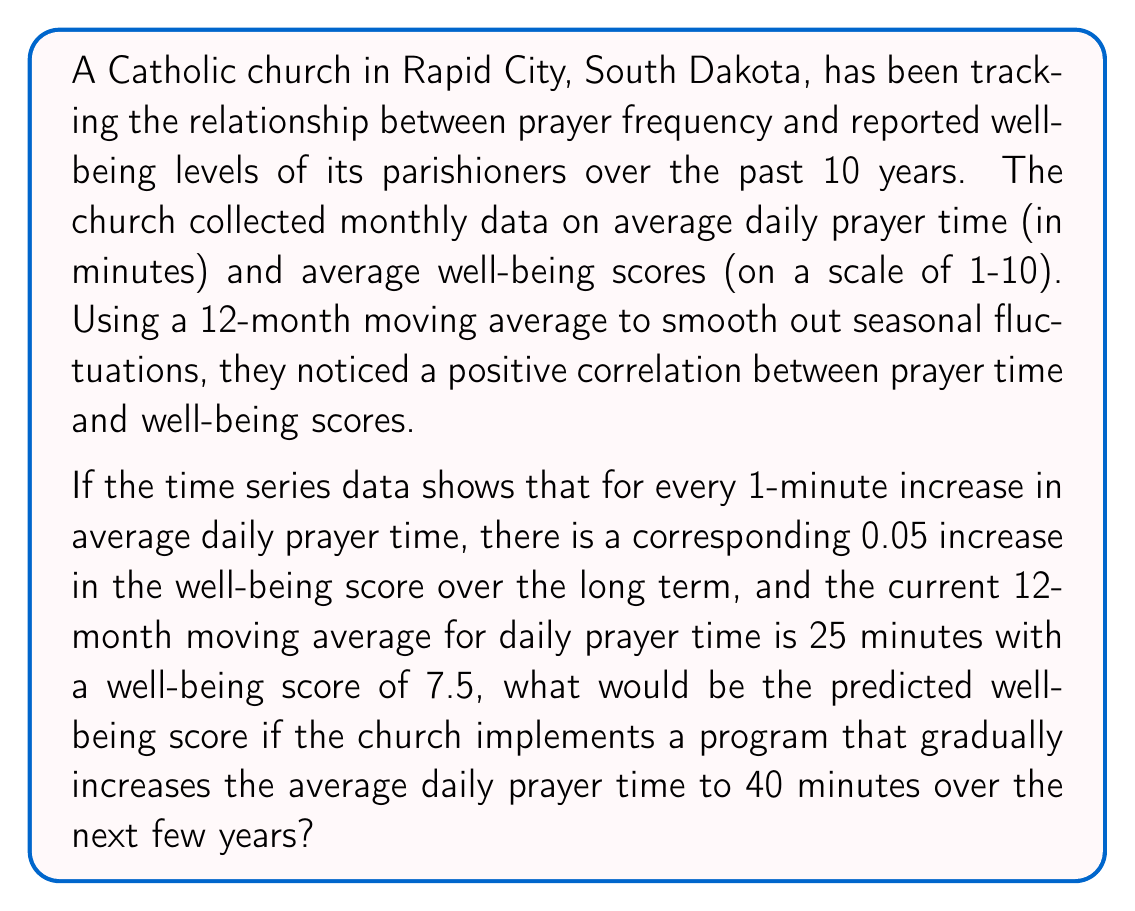Could you help me with this problem? To solve this problem, we need to follow these steps:

1. Understand the given information:
   - There is a positive correlation between prayer time and well-being scores.
   - For every 1-minute increase in average daily prayer time, there is a 0.05 increase in the well-being score.
   - Current 12-month moving average for daily prayer time is 25 minutes.
   - Current well-being score is 7.5.
   - The church plans to increase average daily prayer time to 40 minutes.

2. Calculate the change in prayer time:
   $\Delta \text{Prayer Time} = 40 - 25 = 15$ minutes

3. Calculate the expected change in well-being score:
   $\Delta \text{Well-being} = 15 \times 0.05 = 0.75$

4. Calculate the predicted well-being score:
   $\text{Predicted Well-being} = \text{Current Well-being} + \Delta \text{Well-being}$
   $\text{Predicted Well-being} = 7.5 + 0.75 = 8.25$

The time series analysis suggests that if the church successfully implements the program to increase average daily prayer time to 40 minutes, the predicted well-being score would be 8.25.

It's important to note that this prediction is based on the assumption that the relationship between prayer time and well-being remains constant over time and that no other factors significantly influence the well-being scores.
Answer: The predicted well-being score would be 8.25. 